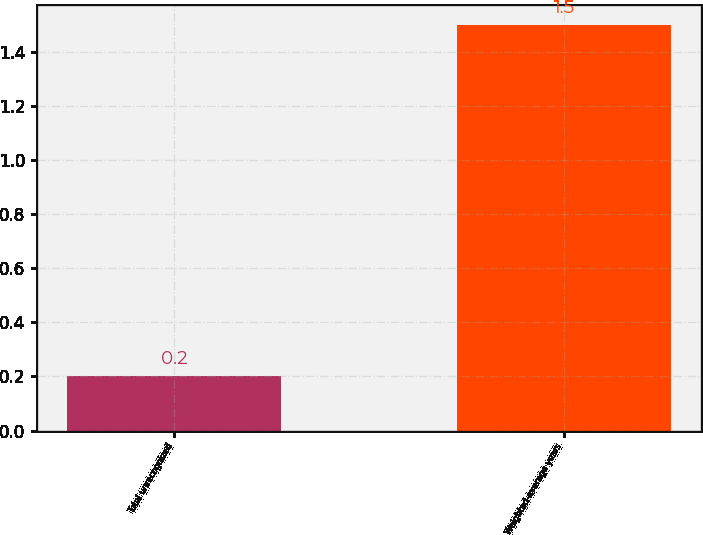<chart> <loc_0><loc_0><loc_500><loc_500><bar_chart><fcel>Total unrecognized<fcel>Weighted-average years<nl><fcel>0.2<fcel>1.5<nl></chart> 